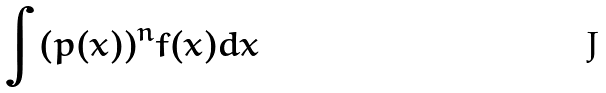<formula> <loc_0><loc_0><loc_500><loc_500>\int ( p ( x ) ) ^ { n } f ( x ) d x</formula> 